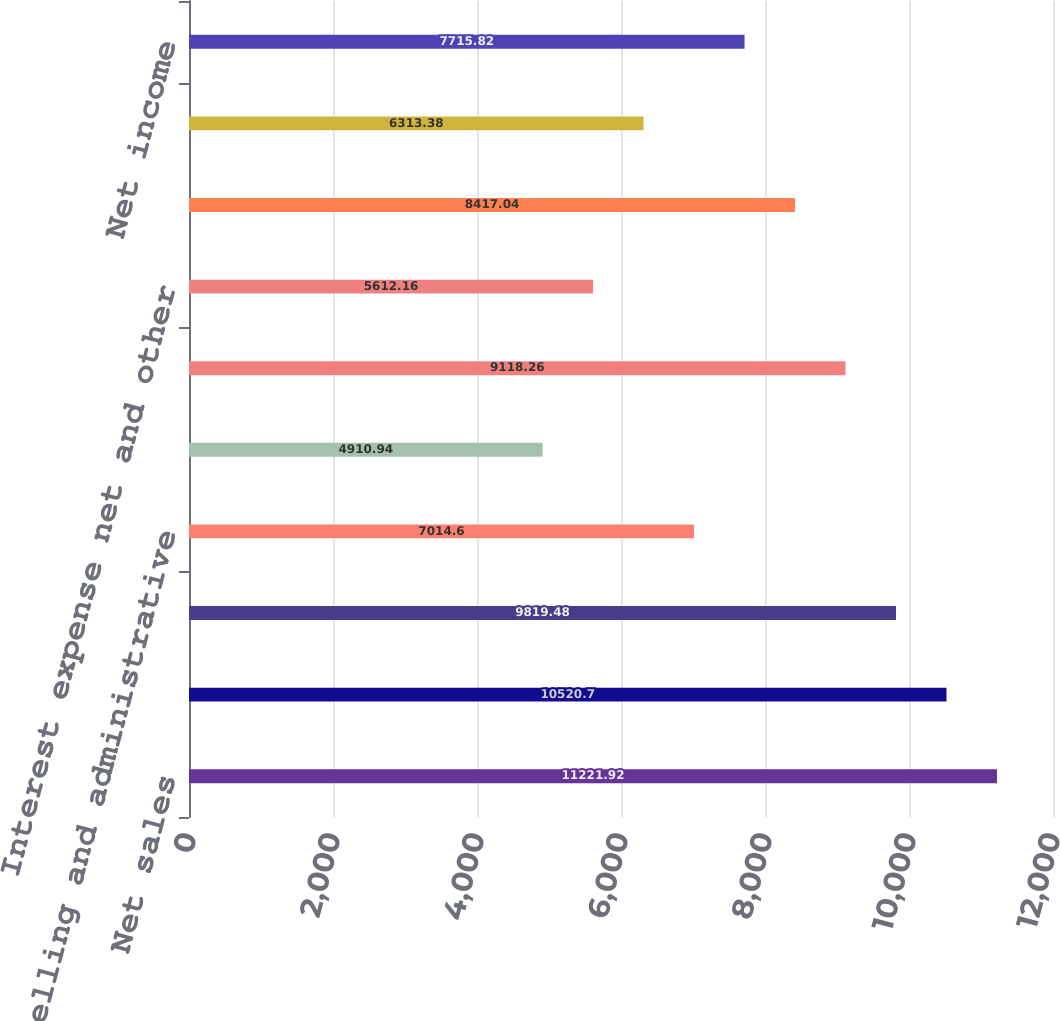<chart> <loc_0><loc_0><loc_500><loc_500><bar_chart><fcel>Net sales<fcel>Cost of sales<fcel>Gross profit<fcel>Selling and administrative<fcel>Other expense net<fcel>Income from operations<fcel>Interest expense net and other<fcel>Income before taxes<fcel>(Provision) benefit for income<fcel>Net income<nl><fcel>11221.9<fcel>10520.7<fcel>9819.48<fcel>7014.6<fcel>4910.94<fcel>9118.26<fcel>5612.16<fcel>8417.04<fcel>6313.38<fcel>7715.82<nl></chart> 